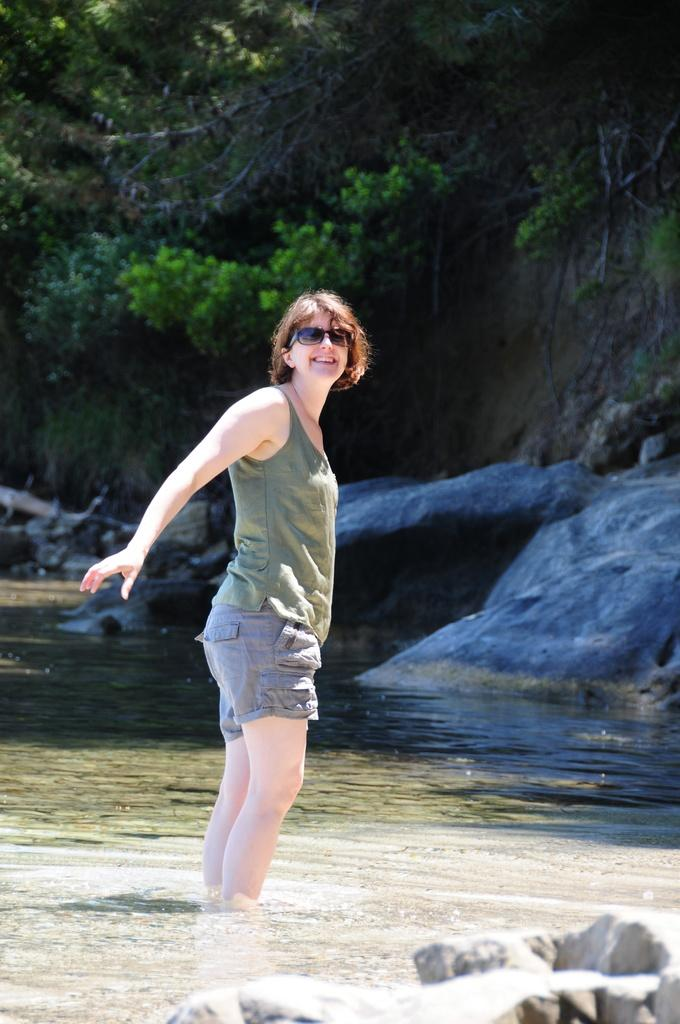What is the woman in the image doing? The woman is standing in the water. What is the woman's facial expression? The woman is smiling. What can be seen in the background of the image? There are trees and rocks in the background. What is visible at the bottom of the image? There is water visible at the bottom of the image. What objects are present in the water? There are stones in the water. What type of volcano can be seen erupting in the background of the image? There is no volcano present in the image; it features a woman standing in the water with trees and rocks in the background. 